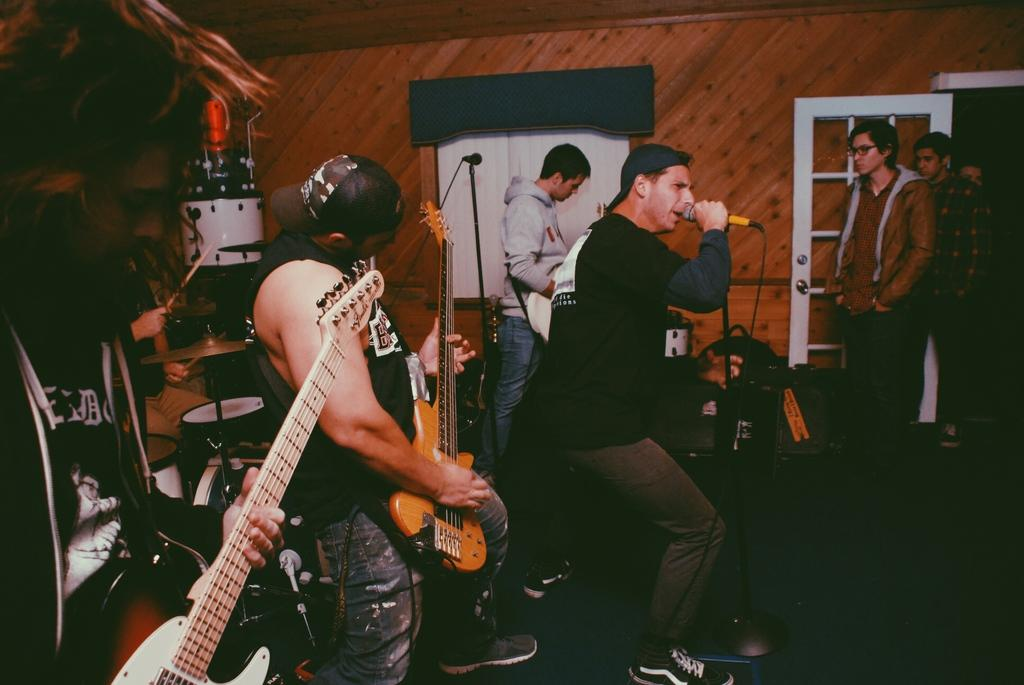What is the main subject of the image? The main subject of the image is a group of people. Where are the people located in the image? The group of people is standing on the right side of the image. What are some of the people in the image doing? There are people holding a microphone and playing the guitar in the image. What type of pie is being served to the crook in the image? There is no crook or pie present in the image. How many chairs are visible in the image? There is no mention of chairs in the provided facts, so we cannot determine the number of chairs in the image. 